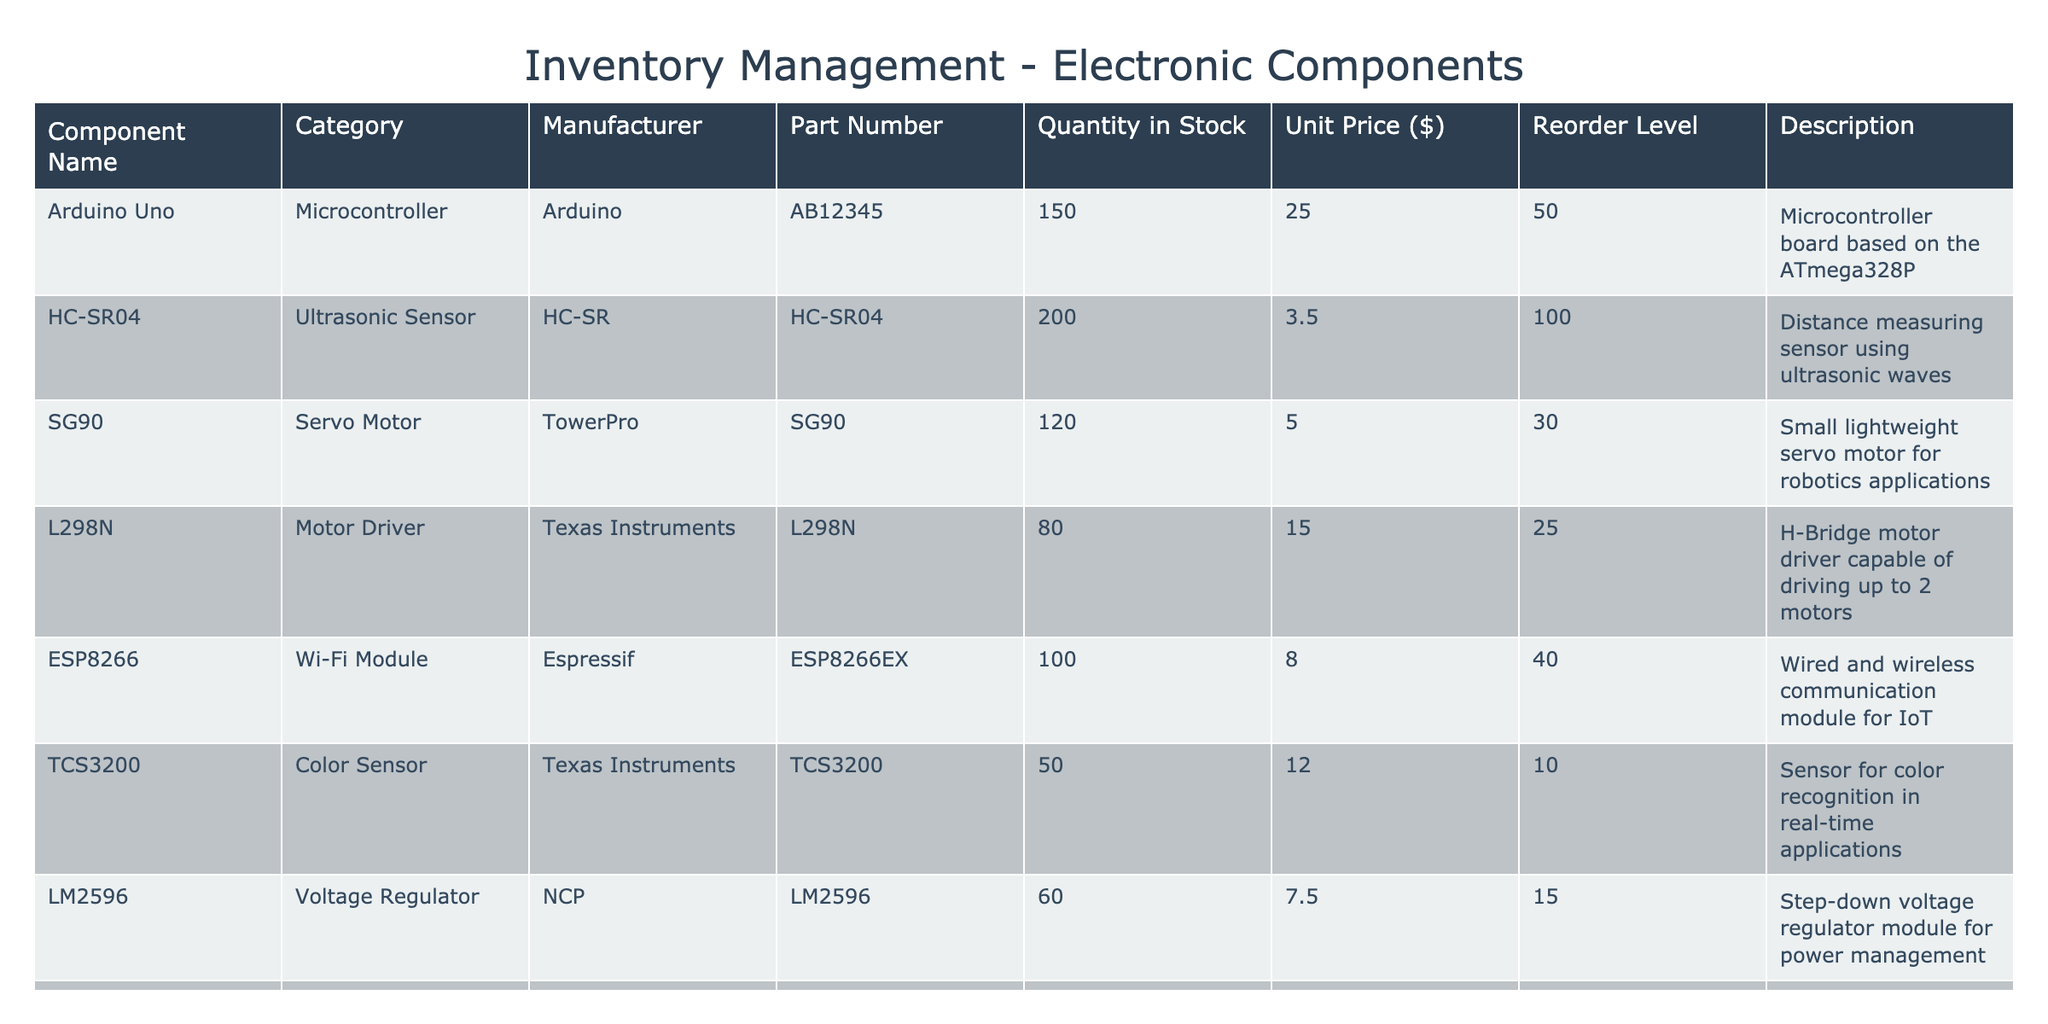What is the quantity in stock for the HC-SR04 ultrasonic sensor? The quantity in stock for the HC-SR04 row can be directly read from the table. The value in the "Quantity in Stock" column for HC-SR04 is 200.
Answer: 200 What is the unit price of the Arduino Uno? The unit price for the Arduino Uno can be found in the "Unit Price ($)" column next to its name. The value is $25.00.
Answer: 25.00 How many components have a reorder level less than or equal to 20? To find this, we need to count the number of components whose "Reorder Level" values are less than or equal to 20. These components are TCS3200, Neopixel Strip, and MAX7219, totaling 3 components.
Answer: 3 Is the servo motor SG90 in stock? To determine if the SG90 is in stock, we check the "Quantity in Stock" for this component. It stands at 120, which is above zero. Therefore, it is indeed in stock.
Answer: Yes What is the total quantity of stock for all components in the inventory? To find the total quantity in stock, we sum up the values in the "Quantity in Stock" column: 150 (Arduino) + 200 (HC-SR04) + 120 (SG90) + 80 (L298N) + 100 (ESP8266) + 50 (TCS3200) + 60 (LM2596) + 90 (Neopixel Strip) + 70 (MAX7219) = 1020.
Answer: 1020 What is the average unit price of the components listed in the inventory? The average unit price can be computed by summing all the unit prices and dividing by the number of components. The total unit price is 25.00 + 3.50 + 5.00 + 15.00 + 8.00 + 12.00 + 7.50 + 20.00 + 5.00 = 105.00. There are 9 components, so the average is 105.00 / 9 ≈ 11.67.
Answer: 11.67 Are any components from Texas Instruments listed in the inventory? We need to check the “Manufacturer” column for any entries labeled Texas Instruments. The L298N and TCS3200 components are both from Texas Instruments, confirming that there are components from this manufacturer.
Answer: Yes What is the difference in quantity in stock between the HC-SR04 and the LM2596? To find the difference, subtract the stock quantity of LM2596 (60) from that of HC-SR04 (200): 200 - 60 = 140. Therefore, the difference is 140 units.
Answer: 140 How many components have a unit price higher than 10 dollars? We need to count the components where the unit price exceeds 10 dollars. The components that meet this criterion are Arduino Uno, TCS3200, Neopixel Strip, which gives us a total of 3 components.
Answer: 3 